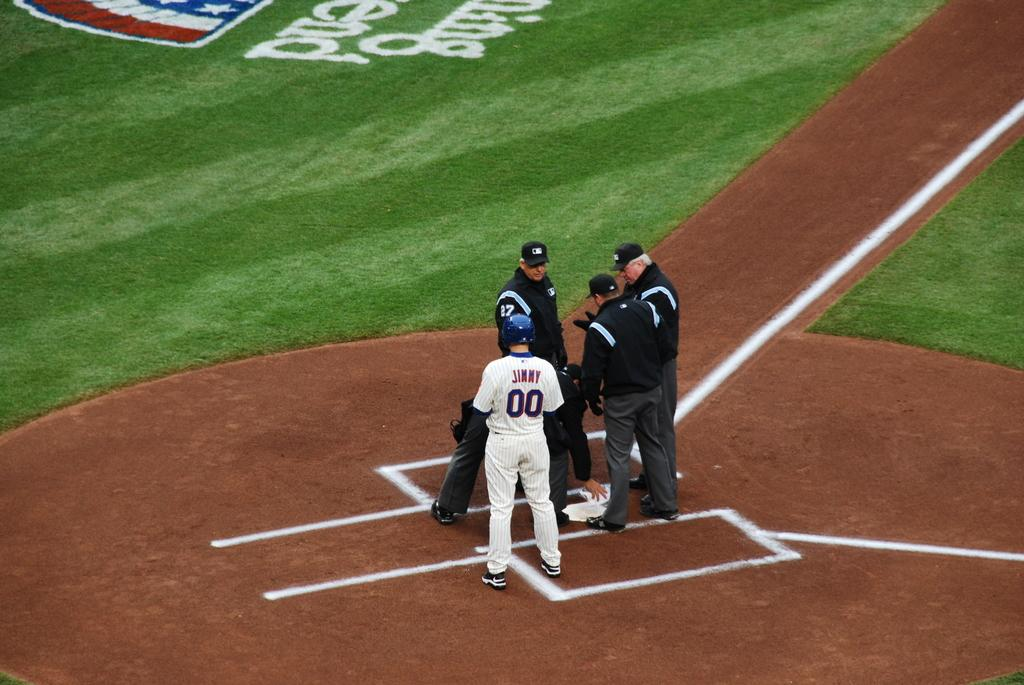<image>
Relay a brief, clear account of the picture shown. The player standing by home plate has the name Jimmy on his back 